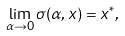<formula> <loc_0><loc_0><loc_500><loc_500>\lim _ { \alpha \to 0 } \sigma ( \alpha , x ) = x ^ { * } ,</formula> 